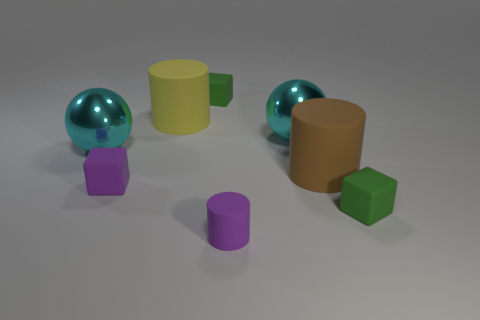How big is the block that is in front of the purple matte block?
Offer a terse response. Small. Is the size of the brown rubber cylinder the same as the purple matte cube?
Your answer should be very brief. No. How many small things are to the right of the large yellow thing and on the left side of the large yellow matte cylinder?
Offer a very short reply. 0. What number of blue objects are large rubber cylinders or big things?
Make the answer very short. 0. How many rubber things are either small purple cylinders or big things?
Make the answer very short. 3. Is there a tiny gray matte block?
Offer a very short reply. No. Do the brown object and the large yellow rubber object have the same shape?
Ensure brevity in your answer.  Yes. There is a big cylinder in front of the large cyan ball that is to the left of the purple cylinder; how many tiny purple cubes are to the right of it?
Offer a terse response. 0. There is a object that is both on the left side of the yellow rubber cylinder and behind the tiny purple cube; what is its material?
Make the answer very short. Metal. The matte cylinder that is both to the left of the brown matte thing and behind the purple rubber cylinder is what color?
Provide a succinct answer. Yellow. 